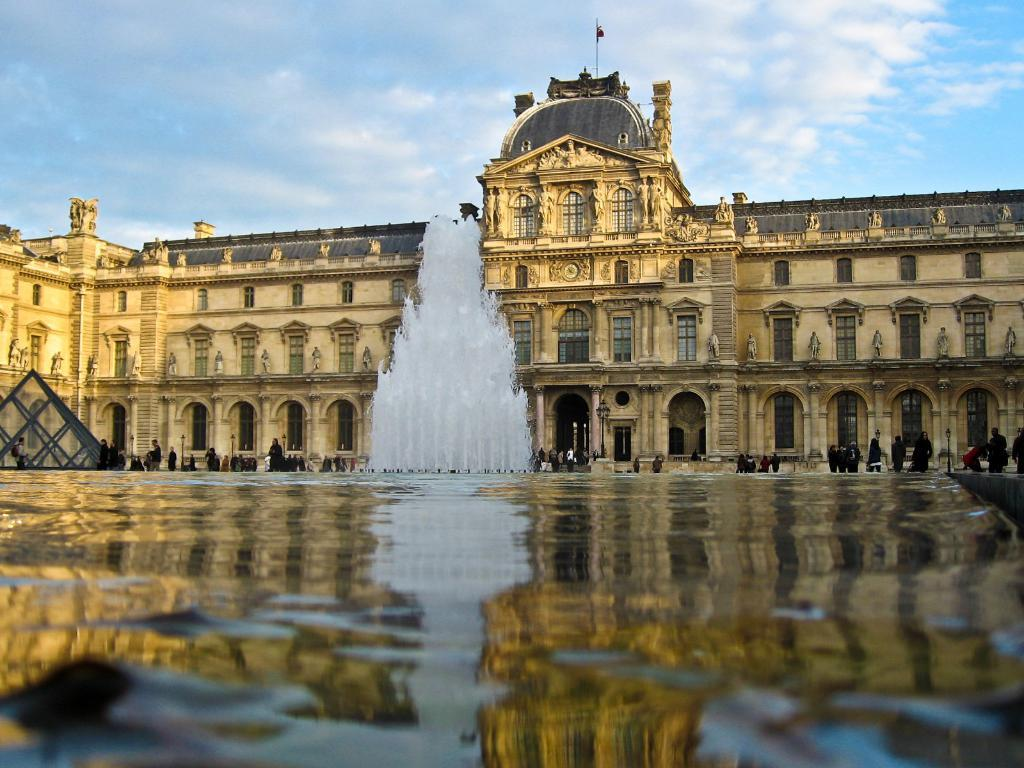What is the main feature in the image? There is a fountain in the image. What can be seen flowing from the fountain? There is water visible in the image. What are the people in the image doing? There are persons standing on the road in the image. What type of structures can be seen in the image? There are poles and a building in the image. Are there any decorative elements in the image? Yes, there are statues in the image. What is attached to the flag post? There is a flag in the image. What is visible in the background of the image? The sky is visible in the background of the image. What type of hole can be seen in the image? There is no hole present in the image. What is the purpose of the meeting taking place in the image? There is no meeting depicted in the image. 